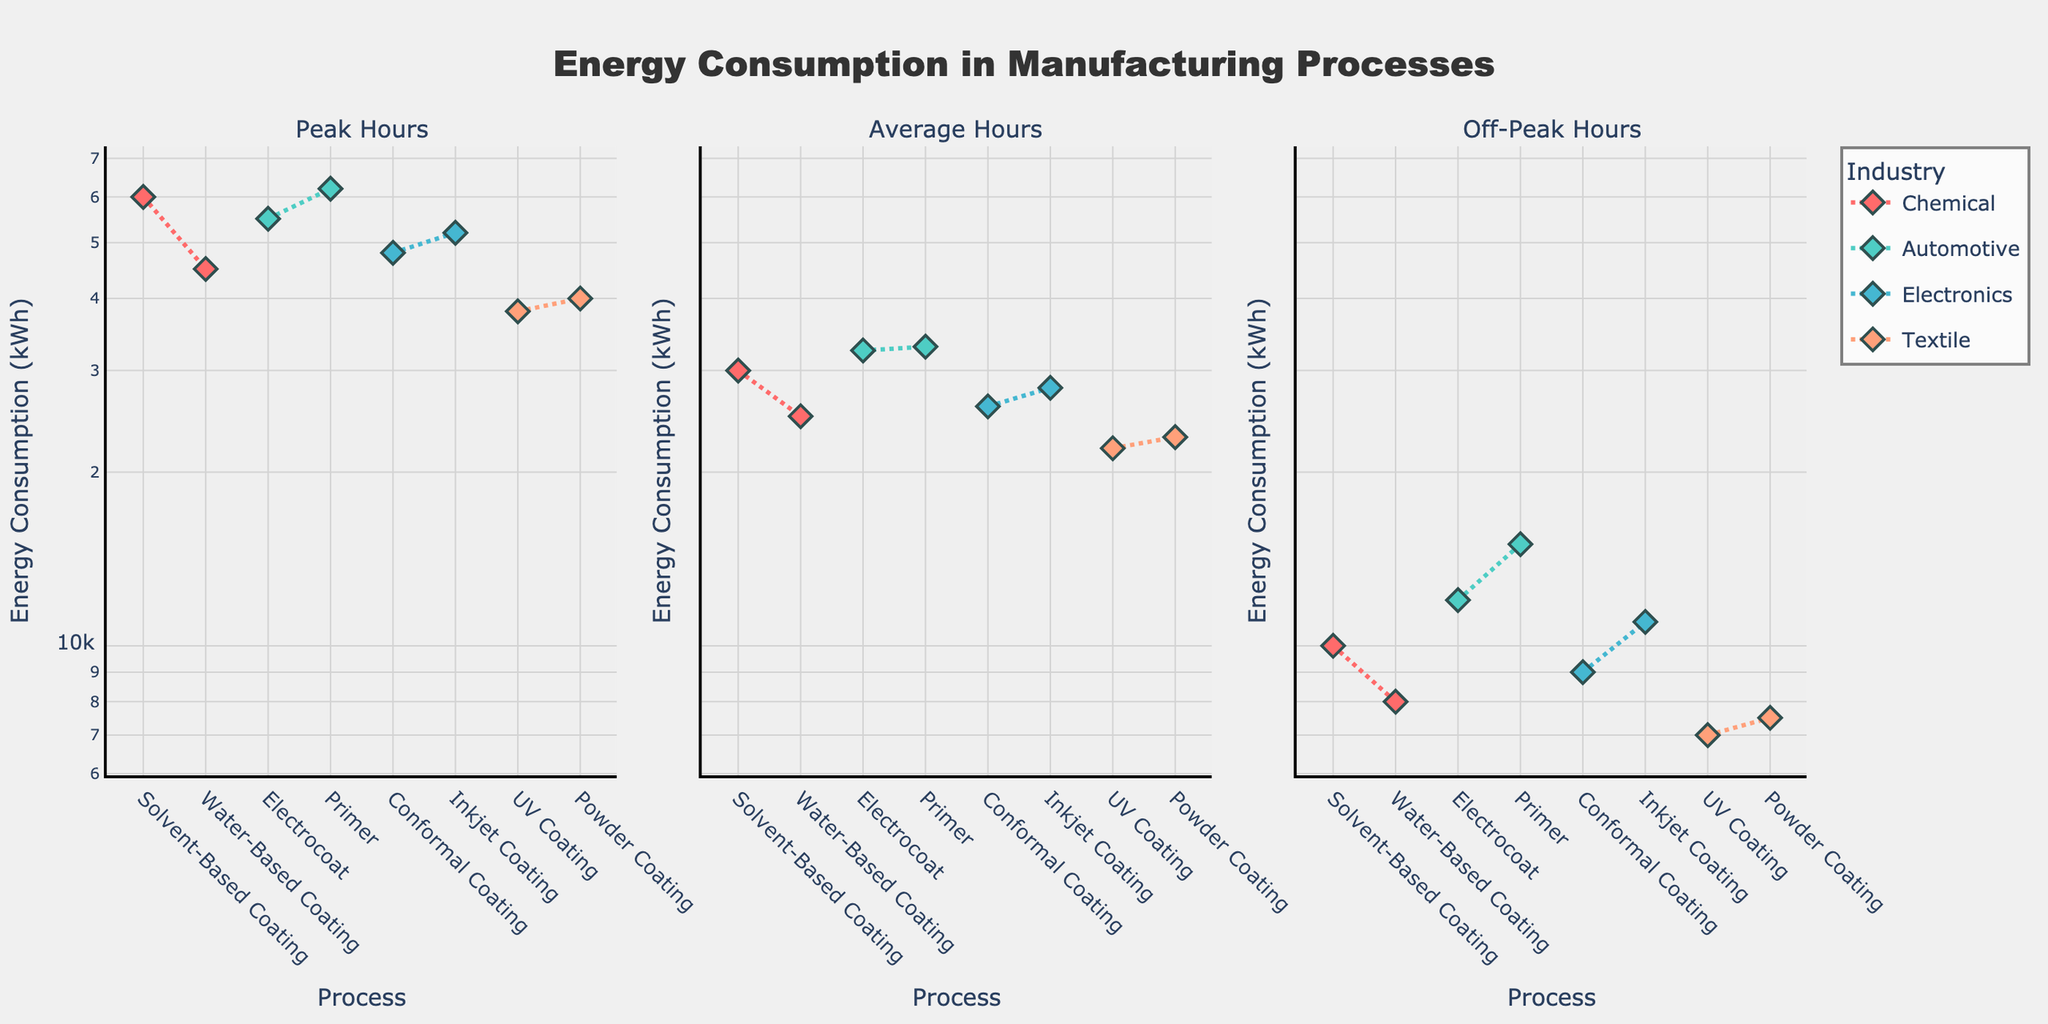What is the title of the figure? The title of the figure is shown at the top center of the plot in bold and large font.
Answer: Energy Consumption in Manufacturing Processes What is the y-axis type used in all subplots? Each y-axis uses a log scale, which can be identified by the evenly spaced logarithmic increments in the tick marks.
Answer: Logarithmic Which industry process has the highest energy consumption during peak hours? From the Peak Hours subplot, the data point with the highest y-value can be identified.
Answer: Primer in Automotive Which process in the Electronics industry uses more energy during average hours, Conformal Coating or Inkjet Coating? Look at the Average Hours subplot and compare the y-values of Conformal Coating and Inkjet Coating within the Electronics industry group.
Answer: Inkjet Coating What is the total energy consumption for the Chemical industry during off-peak hours? Identify the off-peak energy consumption values for Solvent-Based Coating and Water-Based Coating, then sum them up (10000 + 8000).
Answer: 18000 kWh Which industry has the lowest energy consumption for any process during any hour, and what is that value? Find the lowest y-value across all subplots and identify the corresponding industry.
Answer: Textiles, UV Coating during Off-Peak Hours (7000 kWh) How does the energy consumption of Electrocoat during peak hours compare to its average hours in the Automotive industry? In the Peak Hours subplot, identify the y-value for Electrocoat and compare it to the same process's y-value in the Average Hours subplot.
Answer: Electrocoat uses more energy in Peak Hours (55000 kWh) than in Average Hours (32500 kWh) What is the median energy consumption among all processes during average hours? Collect all the average hour energy values, order them, and compute the median value. Values: 30000, 25000, 32500, 33000, 26000, 28000, 22000, 23000. The median of these values is (26000 + 28000) / 2.
Answer: 27000 kWh Which industry shows the smallest relative change in energy consumption between peak hours and off-peak hours? Calculate the relative change (difference divided by peak value) for each industry's processes and find the smallest. For Chemicals: [(60000-10000)/60000, (45000-8000)/45000], Automotives: [(62000-15000)/62000, (55000-12000)/55000], Electronics: [(48000-9000)/48000, (52000-11000)/52000], Textiles: [(38000-7000)/38000, (40000-7500)/40000]. The smallest value is [(45000-8000)/45000] = 0.822.
Answer: Chemical (Water-Based Coating) Which process consumes the least energy during average hours in the Textiles industry? In the Average Hours subplot, compare the y-values of UV Coating and Powder Coating within the Textiles group.
Answer: UV Coating 